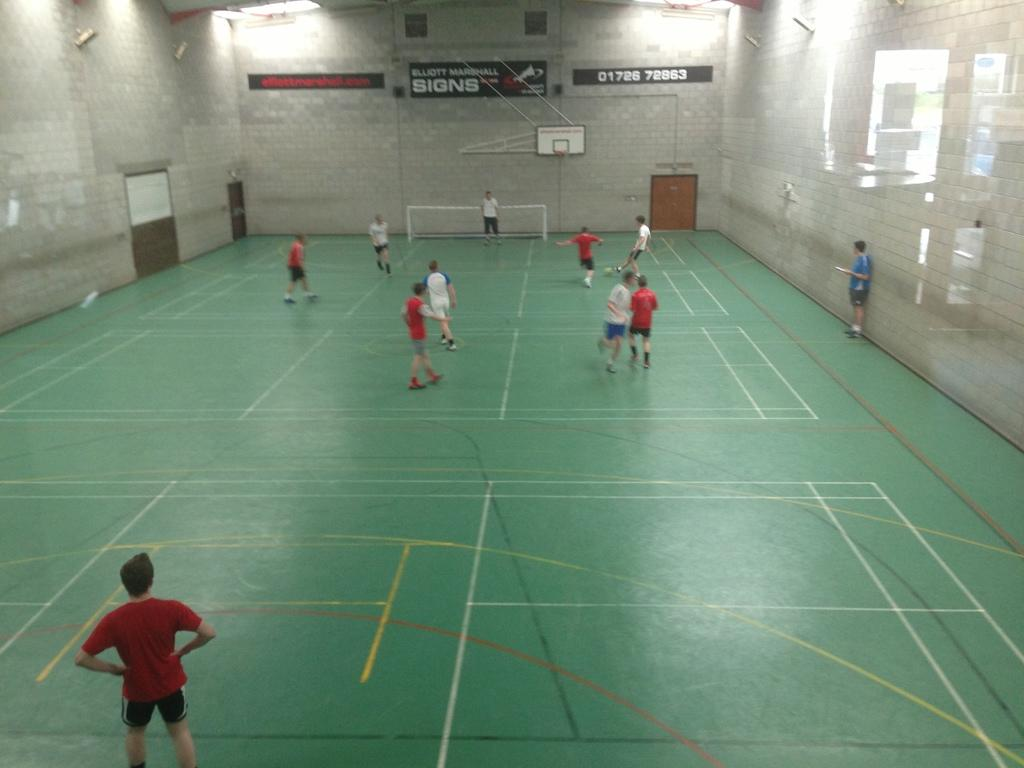<image>
Give a short and clear explanation of the subsequent image. People play soccer on an indoor court with a Elliott Marshall Signs banner on the wall. 